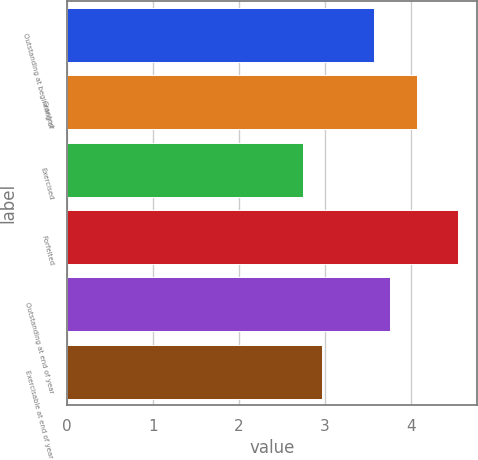<chart> <loc_0><loc_0><loc_500><loc_500><bar_chart><fcel>Outstanding at beginning of<fcel>Granted<fcel>Exercised<fcel>Forfeited<fcel>Outstanding at end of year<fcel>Exercisable at end of year<nl><fcel>3.57<fcel>4.07<fcel>2.74<fcel>4.54<fcel>3.75<fcel>2.96<nl></chart> 